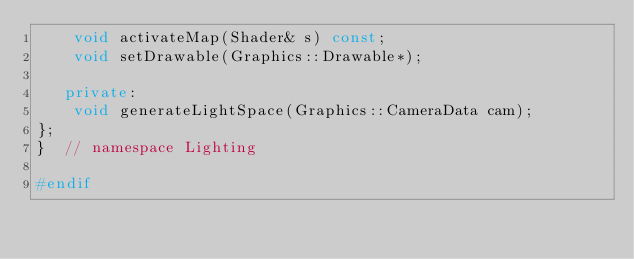<code> <loc_0><loc_0><loc_500><loc_500><_C++_>    void activateMap(Shader& s) const;
    void setDrawable(Graphics::Drawable*);

   private:
    void generateLightSpace(Graphics::CameraData cam);
};
}  // namespace Lighting

#endif</code> 